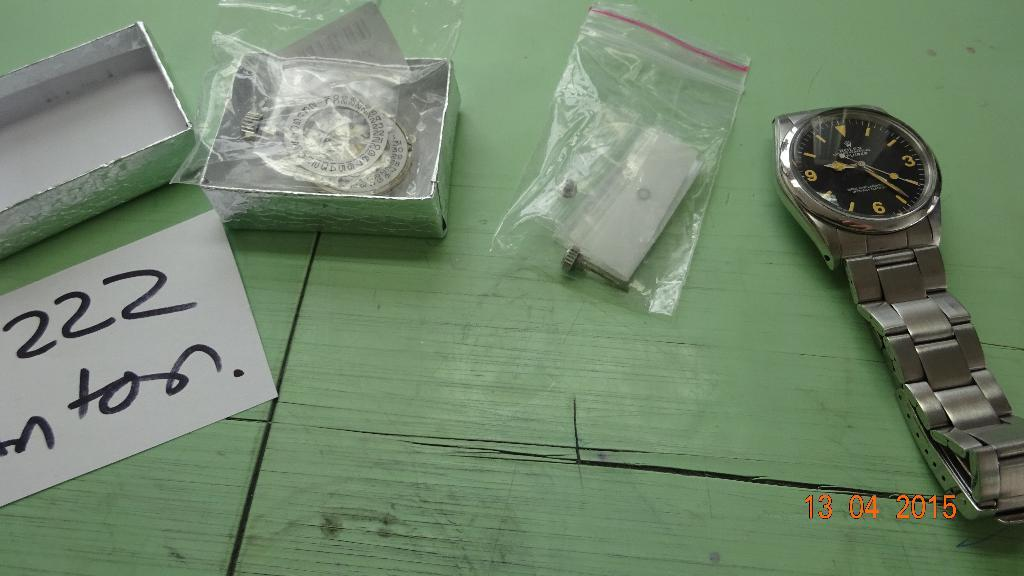<image>
Provide a brief description of the given image. A watch, a paper, amd box with watch parts is shown with a time stamp on the picture 13 04 2015. 